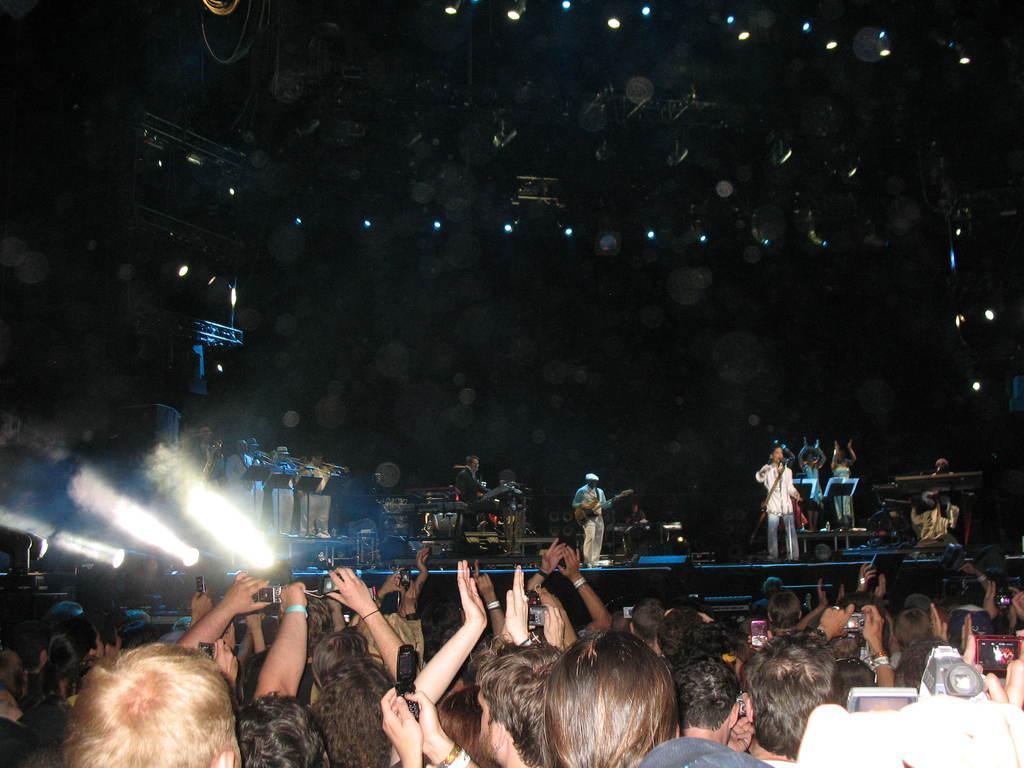Could you give a brief overview of what you see in this image? In this image at the bottom there are many people. In the middle there is a man, he wears a jacket, trouser, he is playing a guitar. On the right there is a man, he wears a shirt, trouser, he is singing. In the middle there are many people, musical instruments, lights, stage, staircase. At the top there are lights. 